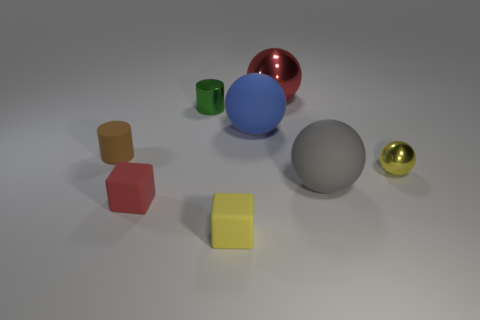Subtract all red balls. How many balls are left? 3 Add 1 small green spheres. How many objects exist? 9 Subtract all gray balls. How many balls are left? 3 Subtract 1 spheres. How many spheres are left? 3 Subtract all cubes. How many objects are left? 6 Subtract all brown balls. Subtract all cyan cubes. How many balls are left? 4 Add 6 green matte cylinders. How many green matte cylinders exist? 6 Subtract 1 gray balls. How many objects are left? 7 Subtract all large metal spheres. Subtract all yellow things. How many objects are left? 5 Add 6 small red rubber things. How many small red rubber things are left? 7 